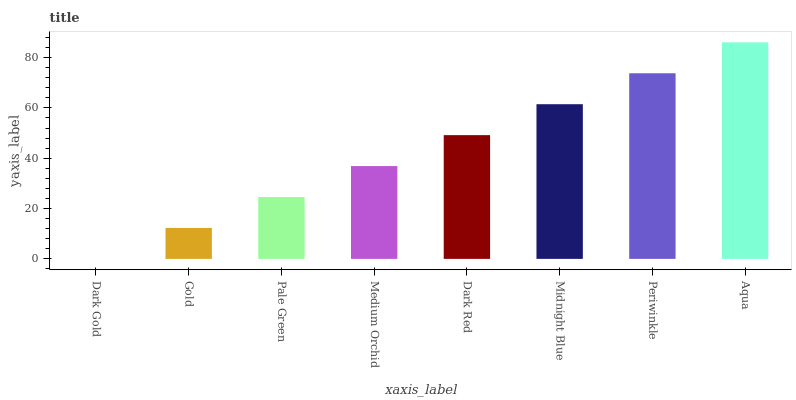Is Dark Gold the minimum?
Answer yes or no. Yes. Is Aqua the maximum?
Answer yes or no. Yes. Is Gold the minimum?
Answer yes or no. No. Is Gold the maximum?
Answer yes or no. No. Is Gold greater than Dark Gold?
Answer yes or no. Yes. Is Dark Gold less than Gold?
Answer yes or no. Yes. Is Dark Gold greater than Gold?
Answer yes or no. No. Is Gold less than Dark Gold?
Answer yes or no. No. Is Dark Red the high median?
Answer yes or no. Yes. Is Medium Orchid the low median?
Answer yes or no. Yes. Is Medium Orchid the high median?
Answer yes or no. No. Is Dark Gold the low median?
Answer yes or no. No. 